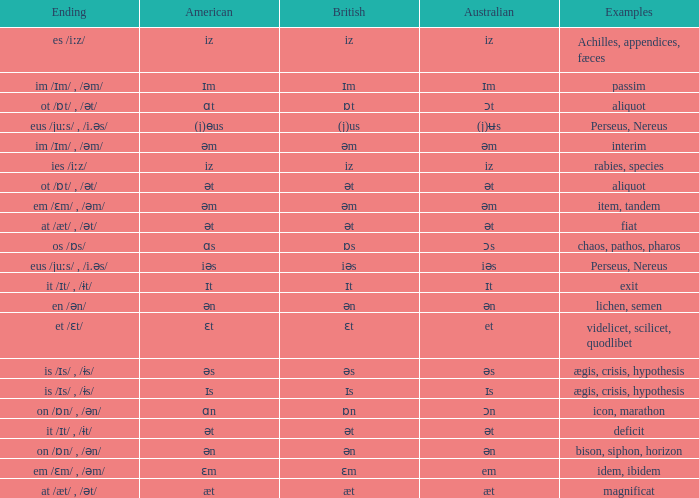Which Australian has British of ɒs? Ɔs. 